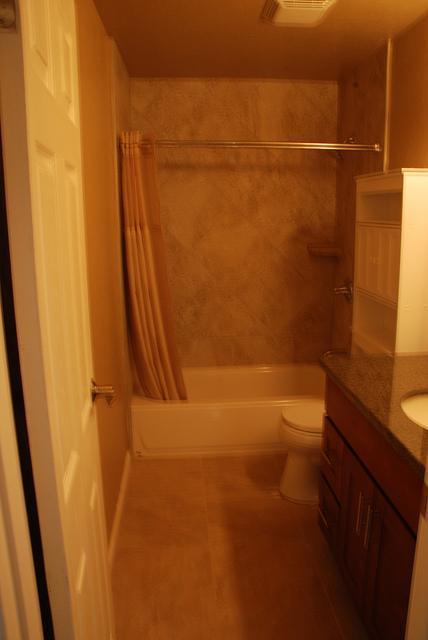How many toilets are in the picture?
Give a very brief answer. 1. 